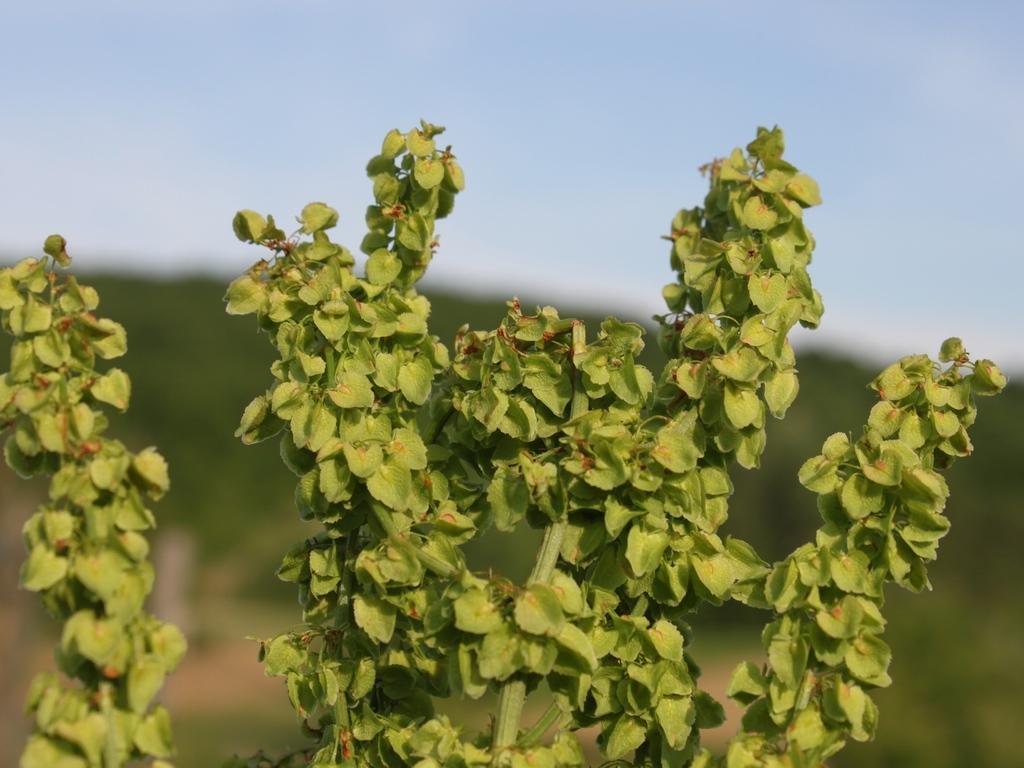Please provide a concise description of this image. This image is taken outdoors. At the top of the image there is the sky with clouds. In this image the background is a little blurred. In the middle of the image there is a plant with green leaves and stems. 